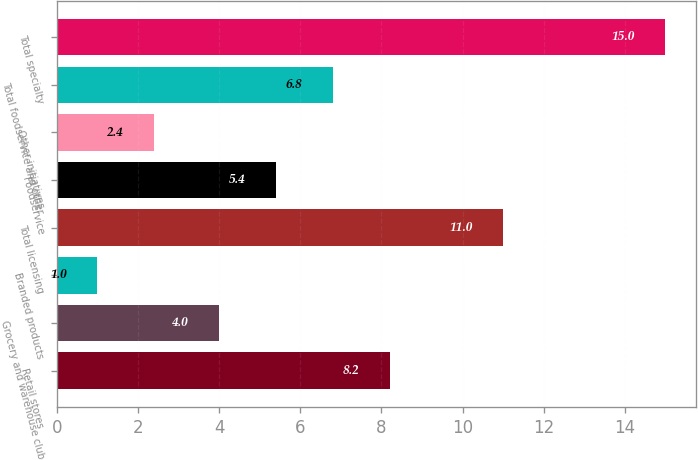Convert chart to OTSL. <chart><loc_0><loc_0><loc_500><loc_500><bar_chart><fcel>Retail stores<fcel>Grocery and warehouse club<fcel>Branded products<fcel>Total licensing<fcel>Foodservice<fcel>Other initiatives<fcel>Total foodservice and other<fcel>Total specialty<nl><fcel>8.2<fcel>4<fcel>1<fcel>11<fcel>5.4<fcel>2.4<fcel>6.8<fcel>15<nl></chart> 